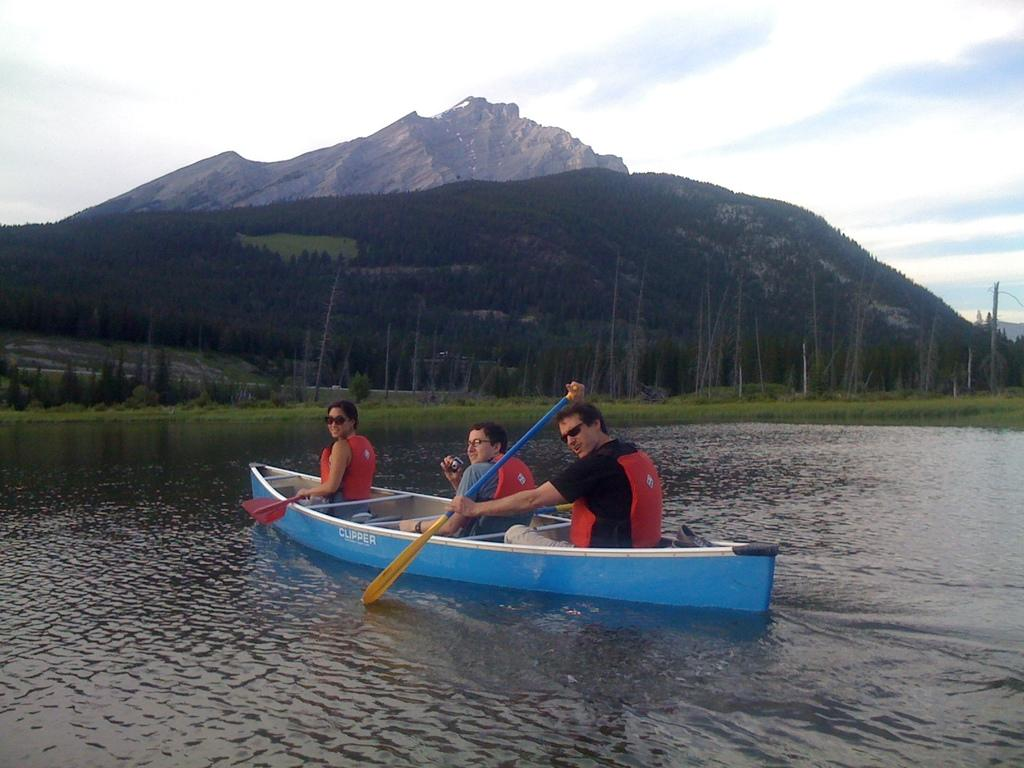How many people are in the image? There are three people in the image. What are the people doing in the image? The people are sitting on a boat. Where is the boat located in the image? The boat is on the water. What can be seen in the background of the image? There are trees, mountains, and the sky visible in the background of the image. What type of book is the person in the middle reading in the image? There is no book present in the image, and the people are not reading. 